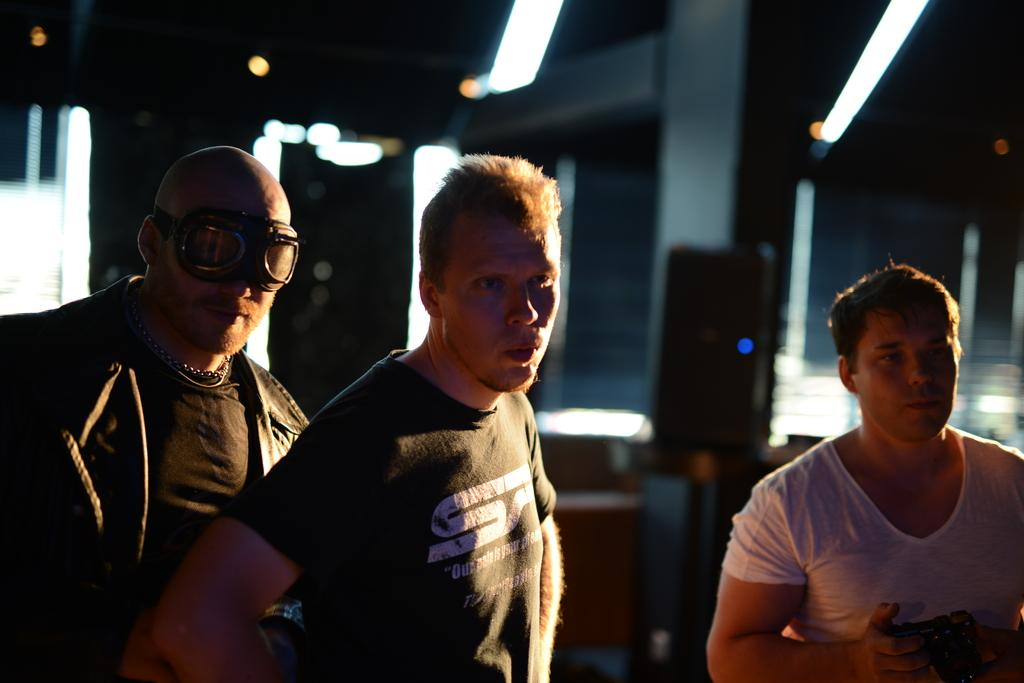How many people are in the image? There are three persons in the image. What is one of the persons doing in the image? One of the persons is holding a camera. Can you describe the background of the image? The background of the image is blurred. What type of game is being played in the image? There is no game being played in the image; it features three persons, one of whom is holding a camera. What kind of paper is visible in the image? There is no paper present in the image. 